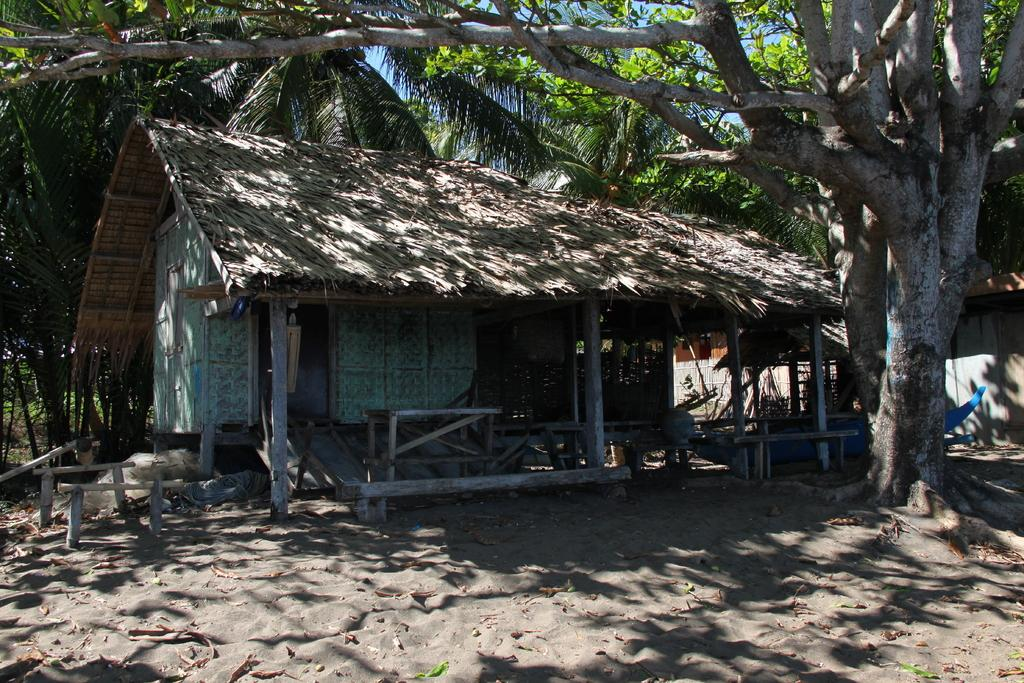What type of structure is in the image? There is a hut in the image. Where is the hut located? The hut is on the ground. What can be seen in the background of the image? There are several trees in the background of the image. What type of cap is the hut wearing in the image? There is no cap present in the image, as the hut is a structure and not a person or animal. 